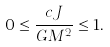<formula> <loc_0><loc_0><loc_500><loc_500>0 \leq { \frac { c J } { G M ^ { 2 } } } \leq 1 .</formula> 